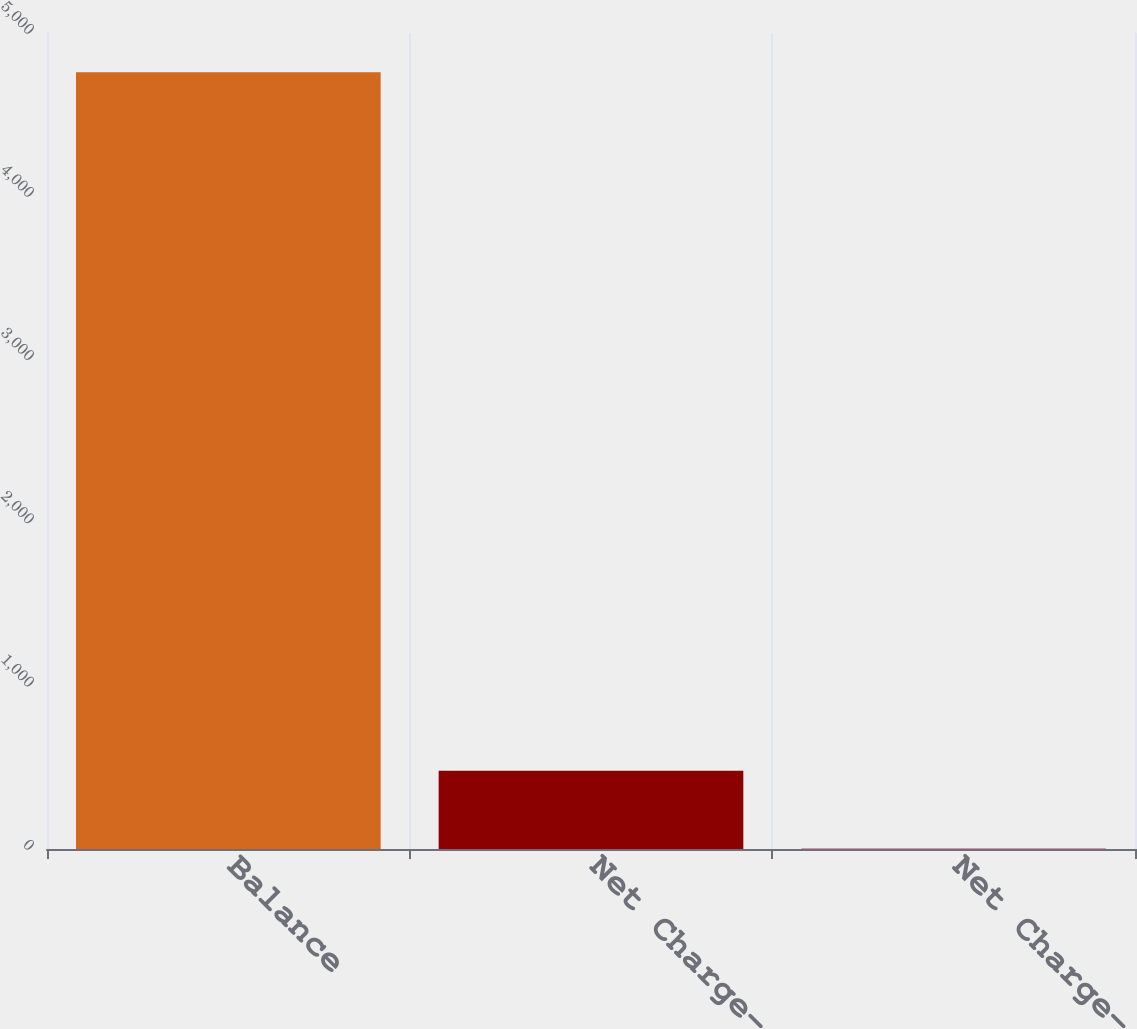Convert chart to OTSL. <chart><loc_0><loc_0><loc_500><loc_500><bar_chart><fcel>Balance<fcel>Net Charge-offs<fcel>Net Charge-off (1)<nl><fcel>4759<fcel>479.9<fcel>4.44<nl></chart> 